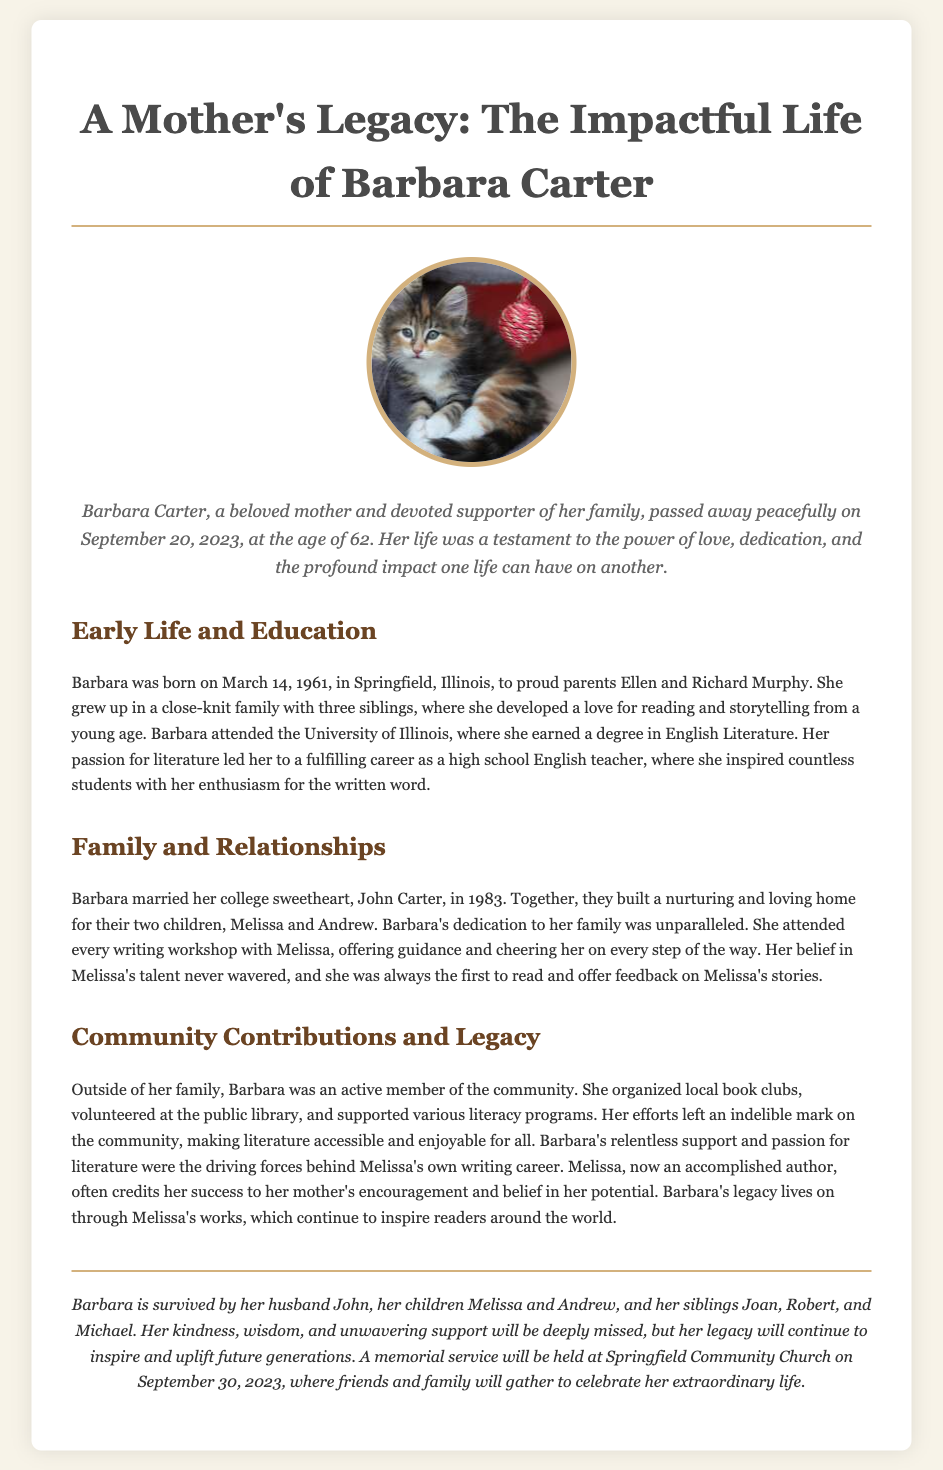What was the birth date of Barbara Carter? The birth date is mentioned in the document, which states that Barbara was born on March 14, 1961.
Answer: March 14, 1961 How old was Barbara at the time of her passing? The document states that Barbara passed away at the age of 62, which can be determined from the information provided.
Answer: 62 Who was Barbara's husband? The document specifically names Barbara's husband as John Carter.
Answer: John Carter What was Barbara's profession? The document describes that Barbara had a fulfilling career as a high school English teacher.
Answer: English teacher What community contributions did Barbara make? The document lists her organization of local book clubs and volunteering at the public library as her community contributions.
Answer: Organized local book clubs and volunteered at the public library What impact did Barbara have on her daughter's writing career? The document mentions that Barbara's relentless support and passion for literature were driving forces behind Melissa's writing career.
Answer: Relentless support and passion for literature Which family member was first to read Melissa's stories? The document states that Barbara was always the first to read and offer feedback on Melissa's stories.
Answer: Barbara When is the memorial service for Barbara? The document provides the date of the memorial service as September 30, 2023.
Answer: September 30, 2023 